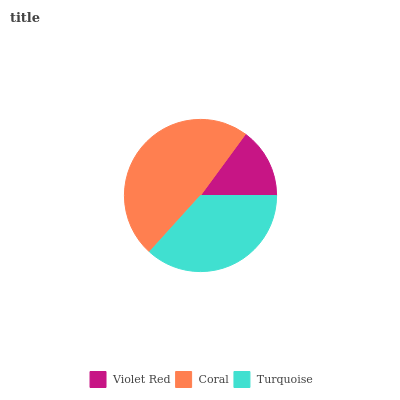Is Violet Red the minimum?
Answer yes or no. Yes. Is Coral the maximum?
Answer yes or no. Yes. Is Turquoise the minimum?
Answer yes or no. No. Is Turquoise the maximum?
Answer yes or no. No. Is Coral greater than Turquoise?
Answer yes or no. Yes. Is Turquoise less than Coral?
Answer yes or no. Yes. Is Turquoise greater than Coral?
Answer yes or no. No. Is Coral less than Turquoise?
Answer yes or no. No. Is Turquoise the high median?
Answer yes or no. Yes. Is Turquoise the low median?
Answer yes or no. Yes. Is Violet Red the high median?
Answer yes or no. No. Is Coral the low median?
Answer yes or no. No. 